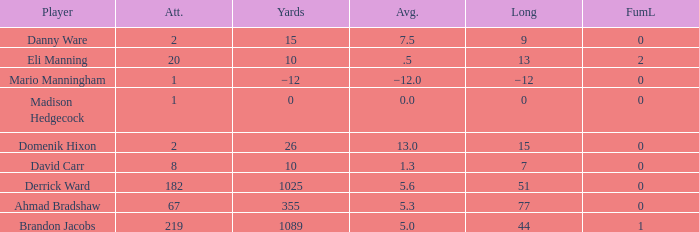What is the mean rushing distance per attempt by domenik hixon? 13.0. 